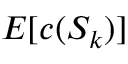Convert formula to latex. <formula><loc_0><loc_0><loc_500><loc_500>E [ c ( S _ { k } ) ]</formula> 